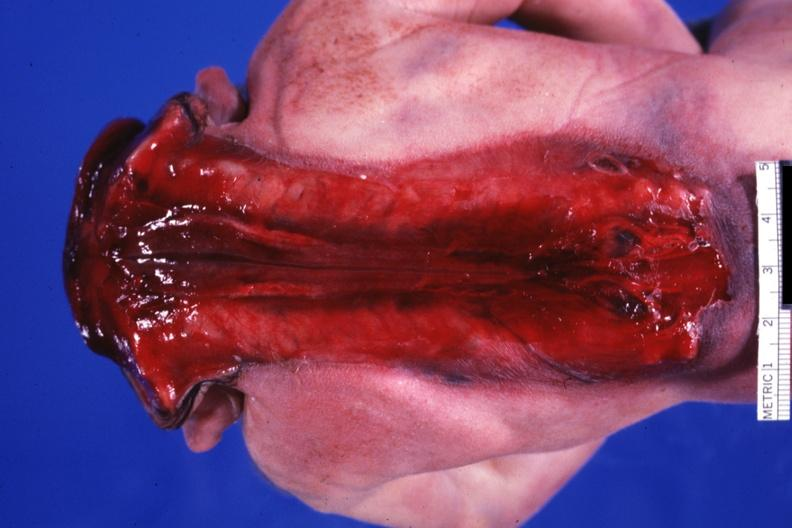s anencephaly with open spine present?
Answer the question using a single word or phrase. Yes 